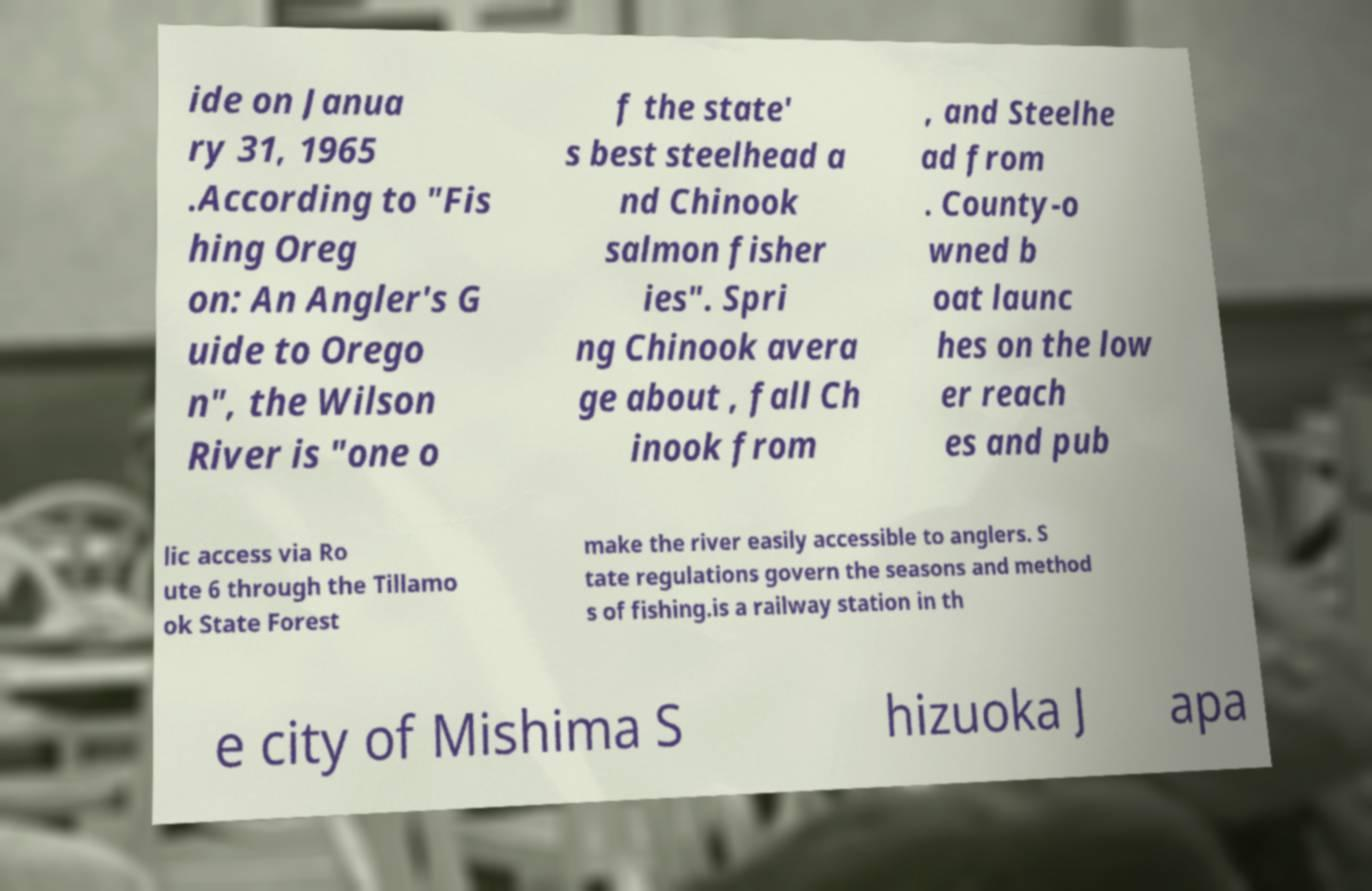Could you assist in decoding the text presented in this image and type it out clearly? ide on Janua ry 31, 1965 .According to "Fis hing Oreg on: An Angler's G uide to Orego n", the Wilson River is "one o f the state' s best steelhead a nd Chinook salmon fisher ies". Spri ng Chinook avera ge about , fall Ch inook from , and Steelhe ad from . County-o wned b oat launc hes on the low er reach es and pub lic access via Ro ute 6 through the Tillamo ok State Forest make the river easily accessible to anglers. S tate regulations govern the seasons and method s of fishing.is a railway station in th e city of Mishima S hizuoka J apa 